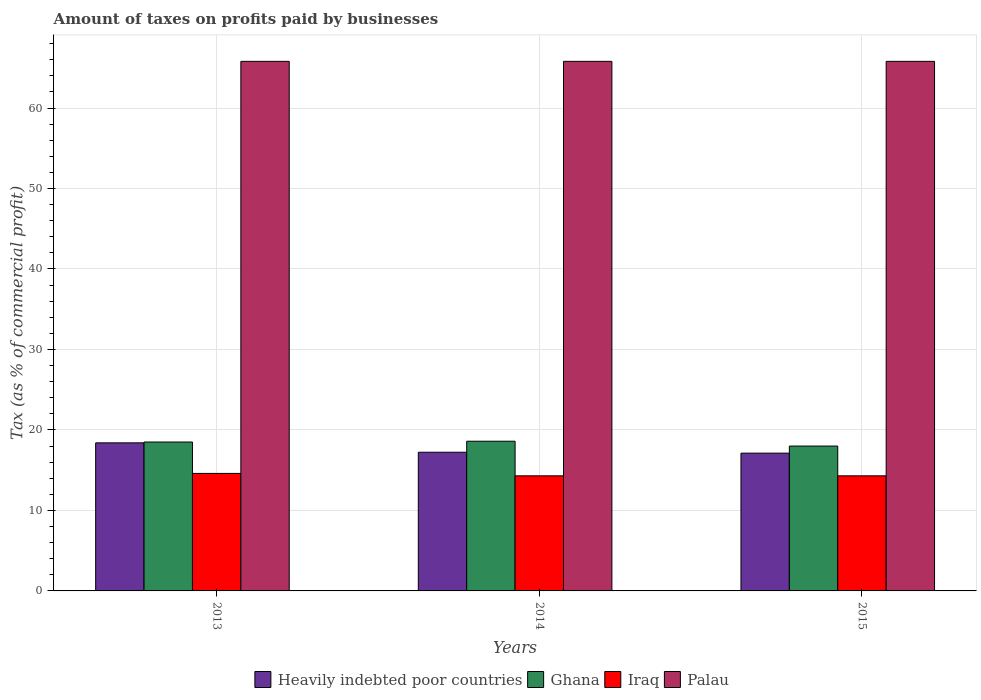Are the number of bars per tick equal to the number of legend labels?
Offer a very short reply. Yes. How many bars are there on the 2nd tick from the left?
Your response must be concise. 4. What is the label of the 3rd group of bars from the left?
Offer a terse response. 2015. In how many cases, is the number of bars for a given year not equal to the number of legend labels?
Offer a terse response. 0. What is the percentage of taxes paid by businesses in Heavily indebted poor countries in 2013?
Provide a short and direct response. 18.4. Across all years, what is the maximum percentage of taxes paid by businesses in Iraq?
Ensure brevity in your answer.  14.6. Across all years, what is the minimum percentage of taxes paid by businesses in Palau?
Provide a short and direct response. 65.8. In which year was the percentage of taxes paid by businesses in Ghana maximum?
Your answer should be compact. 2014. In which year was the percentage of taxes paid by businesses in Ghana minimum?
Offer a very short reply. 2015. What is the total percentage of taxes paid by businesses in Iraq in the graph?
Make the answer very short. 43.2. What is the difference between the percentage of taxes paid by businesses in Iraq in 2015 and the percentage of taxes paid by businesses in Palau in 2014?
Provide a short and direct response. -51.5. What is the average percentage of taxes paid by businesses in Ghana per year?
Your answer should be compact. 18.37. In the year 2015, what is the difference between the percentage of taxes paid by businesses in Iraq and percentage of taxes paid by businesses in Palau?
Ensure brevity in your answer.  -51.5. What is the ratio of the percentage of taxes paid by businesses in Palau in 2013 to that in 2015?
Your response must be concise. 1. What is the difference between the highest and the second highest percentage of taxes paid by businesses in Iraq?
Your response must be concise. 0.3. What is the difference between the highest and the lowest percentage of taxes paid by businesses in Palau?
Make the answer very short. 0. Is it the case that in every year, the sum of the percentage of taxes paid by businesses in Palau and percentage of taxes paid by businesses in Heavily indebted poor countries is greater than the sum of percentage of taxes paid by businesses in Iraq and percentage of taxes paid by businesses in Ghana?
Provide a succinct answer. No. What does the 4th bar from the right in 2015 represents?
Ensure brevity in your answer.  Heavily indebted poor countries. How many bars are there?
Offer a very short reply. 12. Are all the bars in the graph horizontal?
Your answer should be compact. No. How many years are there in the graph?
Provide a short and direct response. 3. Does the graph contain grids?
Your answer should be compact. Yes. Where does the legend appear in the graph?
Keep it short and to the point. Bottom center. What is the title of the graph?
Provide a short and direct response. Amount of taxes on profits paid by businesses. What is the label or title of the Y-axis?
Make the answer very short. Tax (as % of commercial profit). What is the Tax (as % of commercial profit) of Heavily indebted poor countries in 2013?
Provide a short and direct response. 18.4. What is the Tax (as % of commercial profit) of Ghana in 2013?
Your answer should be compact. 18.5. What is the Tax (as % of commercial profit) in Palau in 2013?
Ensure brevity in your answer.  65.8. What is the Tax (as % of commercial profit) in Heavily indebted poor countries in 2014?
Your response must be concise. 17.23. What is the Tax (as % of commercial profit) of Ghana in 2014?
Ensure brevity in your answer.  18.6. What is the Tax (as % of commercial profit) of Palau in 2014?
Offer a very short reply. 65.8. What is the Tax (as % of commercial profit) of Heavily indebted poor countries in 2015?
Keep it short and to the point. 17.12. What is the Tax (as % of commercial profit) in Palau in 2015?
Your answer should be compact. 65.8. Across all years, what is the maximum Tax (as % of commercial profit) of Heavily indebted poor countries?
Your response must be concise. 18.4. Across all years, what is the maximum Tax (as % of commercial profit) of Ghana?
Provide a succinct answer. 18.6. Across all years, what is the maximum Tax (as % of commercial profit) of Palau?
Make the answer very short. 65.8. Across all years, what is the minimum Tax (as % of commercial profit) in Heavily indebted poor countries?
Ensure brevity in your answer.  17.12. Across all years, what is the minimum Tax (as % of commercial profit) of Palau?
Offer a very short reply. 65.8. What is the total Tax (as % of commercial profit) in Heavily indebted poor countries in the graph?
Your response must be concise. 52.75. What is the total Tax (as % of commercial profit) in Ghana in the graph?
Your response must be concise. 55.1. What is the total Tax (as % of commercial profit) of Iraq in the graph?
Ensure brevity in your answer.  43.2. What is the total Tax (as % of commercial profit) in Palau in the graph?
Your response must be concise. 197.4. What is the difference between the Tax (as % of commercial profit) of Heavily indebted poor countries in 2013 and that in 2014?
Your answer should be compact. 1.17. What is the difference between the Tax (as % of commercial profit) of Ghana in 2013 and that in 2014?
Your response must be concise. -0.1. What is the difference between the Tax (as % of commercial profit) in Palau in 2013 and that in 2014?
Your answer should be very brief. 0. What is the difference between the Tax (as % of commercial profit) in Heavily indebted poor countries in 2013 and that in 2015?
Keep it short and to the point. 1.28. What is the difference between the Tax (as % of commercial profit) in Ghana in 2013 and that in 2015?
Make the answer very short. 0.5. What is the difference between the Tax (as % of commercial profit) in Iraq in 2013 and that in 2015?
Ensure brevity in your answer.  0.3. What is the difference between the Tax (as % of commercial profit) of Palau in 2013 and that in 2015?
Your answer should be very brief. 0. What is the difference between the Tax (as % of commercial profit) of Heavily indebted poor countries in 2014 and that in 2015?
Your answer should be very brief. 0.11. What is the difference between the Tax (as % of commercial profit) of Heavily indebted poor countries in 2013 and the Tax (as % of commercial profit) of Ghana in 2014?
Ensure brevity in your answer.  -0.2. What is the difference between the Tax (as % of commercial profit) of Heavily indebted poor countries in 2013 and the Tax (as % of commercial profit) of Iraq in 2014?
Provide a succinct answer. 4.1. What is the difference between the Tax (as % of commercial profit) in Heavily indebted poor countries in 2013 and the Tax (as % of commercial profit) in Palau in 2014?
Provide a short and direct response. -47.4. What is the difference between the Tax (as % of commercial profit) in Ghana in 2013 and the Tax (as % of commercial profit) in Palau in 2014?
Ensure brevity in your answer.  -47.3. What is the difference between the Tax (as % of commercial profit) of Iraq in 2013 and the Tax (as % of commercial profit) of Palau in 2014?
Provide a short and direct response. -51.2. What is the difference between the Tax (as % of commercial profit) in Heavily indebted poor countries in 2013 and the Tax (as % of commercial profit) in Ghana in 2015?
Your response must be concise. 0.4. What is the difference between the Tax (as % of commercial profit) of Heavily indebted poor countries in 2013 and the Tax (as % of commercial profit) of Iraq in 2015?
Your answer should be compact. 4.1. What is the difference between the Tax (as % of commercial profit) of Heavily indebted poor countries in 2013 and the Tax (as % of commercial profit) of Palau in 2015?
Keep it short and to the point. -47.4. What is the difference between the Tax (as % of commercial profit) of Ghana in 2013 and the Tax (as % of commercial profit) of Iraq in 2015?
Your answer should be compact. 4.2. What is the difference between the Tax (as % of commercial profit) in Ghana in 2013 and the Tax (as % of commercial profit) in Palau in 2015?
Make the answer very short. -47.3. What is the difference between the Tax (as % of commercial profit) of Iraq in 2013 and the Tax (as % of commercial profit) of Palau in 2015?
Ensure brevity in your answer.  -51.2. What is the difference between the Tax (as % of commercial profit) in Heavily indebted poor countries in 2014 and the Tax (as % of commercial profit) in Ghana in 2015?
Your answer should be very brief. -0.77. What is the difference between the Tax (as % of commercial profit) in Heavily indebted poor countries in 2014 and the Tax (as % of commercial profit) in Iraq in 2015?
Keep it short and to the point. 2.93. What is the difference between the Tax (as % of commercial profit) in Heavily indebted poor countries in 2014 and the Tax (as % of commercial profit) in Palau in 2015?
Keep it short and to the point. -48.57. What is the difference between the Tax (as % of commercial profit) in Ghana in 2014 and the Tax (as % of commercial profit) in Iraq in 2015?
Your answer should be compact. 4.3. What is the difference between the Tax (as % of commercial profit) of Ghana in 2014 and the Tax (as % of commercial profit) of Palau in 2015?
Offer a very short reply. -47.2. What is the difference between the Tax (as % of commercial profit) of Iraq in 2014 and the Tax (as % of commercial profit) of Palau in 2015?
Provide a short and direct response. -51.5. What is the average Tax (as % of commercial profit) of Heavily indebted poor countries per year?
Offer a very short reply. 17.58. What is the average Tax (as % of commercial profit) in Ghana per year?
Provide a succinct answer. 18.37. What is the average Tax (as % of commercial profit) in Iraq per year?
Give a very brief answer. 14.4. What is the average Tax (as % of commercial profit) in Palau per year?
Offer a terse response. 65.8. In the year 2013, what is the difference between the Tax (as % of commercial profit) in Heavily indebted poor countries and Tax (as % of commercial profit) in Ghana?
Your answer should be very brief. -0.1. In the year 2013, what is the difference between the Tax (as % of commercial profit) of Heavily indebted poor countries and Tax (as % of commercial profit) of Iraq?
Ensure brevity in your answer.  3.8. In the year 2013, what is the difference between the Tax (as % of commercial profit) in Heavily indebted poor countries and Tax (as % of commercial profit) in Palau?
Keep it short and to the point. -47.4. In the year 2013, what is the difference between the Tax (as % of commercial profit) of Ghana and Tax (as % of commercial profit) of Iraq?
Make the answer very short. 3.9. In the year 2013, what is the difference between the Tax (as % of commercial profit) in Ghana and Tax (as % of commercial profit) in Palau?
Ensure brevity in your answer.  -47.3. In the year 2013, what is the difference between the Tax (as % of commercial profit) of Iraq and Tax (as % of commercial profit) of Palau?
Provide a succinct answer. -51.2. In the year 2014, what is the difference between the Tax (as % of commercial profit) of Heavily indebted poor countries and Tax (as % of commercial profit) of Ghana?
Make the answer very short. -1.37. In the year 2014, what is the difference between the Tax (as % of commercial profit) in Heavily indebted poor countries and Tax (as % of commercial profit) in Iraq?
Keep it short and to the point. 2.93. In the year 2014, what is the difference between the Tax (as % of commercial profit) of Heavily indebted poor countries and Tax (as % of commercial profit) of Palau?
Your response must be concise. -48.57. In the year 2014, what is the difference between the Tax (as % of commercial profit) in Ghana and Tax (as % of commercial profit) in Iraq?
Give a very brief answer. 4.3. In the year 2014, what is the difference between the Tax (as % of commercial profit) in Ghana and Tax (as % of commercial profit) in Palau?
Provide a short and direct response. -47.2. In the year 2014, what is the difference between the Tax (as % of commercial profit) in Iraq and Tax (as % of commercial profit) in Palau?
Make the answer very short. -51.5. In the year 2015, what is the difference between the Tax (as % of commercial profit) in Heavily indebted poor countries and Tax (as % of commercial profit) in Ghana?
Keep it short and to the point. -0.88. In the year 2015, what is the difference between the Tax (as % of commercial profit) in Heavily indebted poor countries and Tax (as % of commercial profit) in Iraq?
Make the answer very short. 2.82. In the year 2015, what is the difference between the Tax (as % of commercial profit) of Heavily indebted poor countries and Tax (as % of commercial profit) of Palau?
Offer a very short reply. -48.68. In the year 2015, what is the difference between the Tax (as % of commercial profit) of Ghana and Tax (as % of commercial profit) of Palau?
Your answer should be very brief. -47.8. In the year 2015, what is the difference between the Tax (as % of commercial profit) in Iraq and Tax (as % of commercial profit) in Palau?
Your answer should be compact. -51.5. What is the ratio of the Tax (as % of commercial profit) of Heavily indebted poor countries in 2013 to that in 2014?
Give a very brief answer. 1.07. What is the ratio of the Tax (as % of commercial profit) of Palau in 2013 to that in 2014?
Provide a short and direct response. 1. What is the ratio of the Tax (as % of commercial profit) of Heavily indebted poor countries in 2013 to that in 2015?
Give a very brief answer. 1.07. What is the ratio of the Tax (as % of commercial profit) in Ghana in 2013 to that in 2015?
Ensure brevity in your answer.  1.03. What is the ratio of the Tax (as % of commercial profit) of Heavily indebted poor countries in 2014 to that in 2015?
Offer a terse response. 1.01. What is the ratio of the Tax (as % of commercial profit) of Iraq in 2014 to that in 2015?
Make the answer very short. 1. What is the difference between the highest and the second highest Tax (as % of commercial profit) in Heavily indebted poor countries?
Ensure brevity in your answer.  1.17. What is the difference between the highest and the second highest Tax (as % of commercial profit) in Ghana?
Offer a terse response. 0.1. What is the difference between the highest and the lowest Tax (as % of commercial profit) of Heavily indebted poor countries?
Your answer should be very brief. 1.28. What is the difference between the highest and the lowest Tax (as % of commercial profit) of Ghana?
Offer a very short reply. 0.6. What is the difference between the highest and the lowest Tax (as % of commercial profit) in Palau?
Your answer should be very brief. 0. 